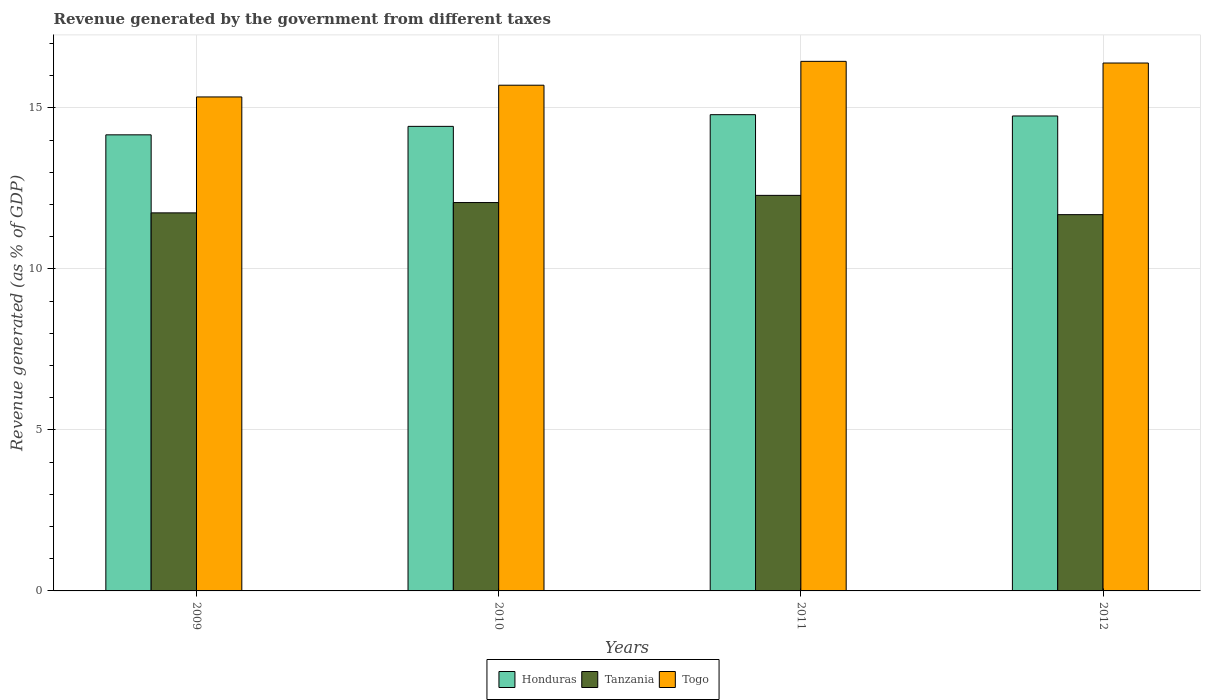Are the number of bars per tick equal to the number of legend labels?
Offer a terse response. Yes. Are the number of bars on each tick of the X-axis equal?
Give a very brief answer. Yes. How many bars are there on the 2nd tick from the right?
Make the answer very short. 3. What is the label of the 3rd group of bars from the left?
Give a very brief answer. 2011. What is the revenue generated by the government in Togo in 2012?
Your response must be concise. 16.39. Across all years, what is the maximum revenue generated by the government in Honduras?
Your response must be concise. 14.79. Across all years, what is the minimum revenue generated by the government in Togo?
Give a very brief answer. 15.34. In which year was the revenue generated by the government in Honduras maximum?
Keep it short and to the point. 2011. In which year was the revenue generated by the government in Togo minimum?
Give a very brief answer. 2009. What is the total revenue generated by the government in Togo in the graph?
Ensure brevity in your answer.  63.88. What is the difference between the revenue generated by the government in Togo in 2010 and that in 2011?
Keep it short and to the point. -0.74. What is the difference between the revenue generated by the government in Tanzania in 2010 and the revenue generated by the government in Honduras in 2012?
Provide a short and direct response. -2.69. What is the average revenue generated by the government in Togo per year?
Offer a very short reply. 15.97. In the year 2009, what is the difference between the revenue generated by the government in Tanzania and revenue generated by the government in Togo?
Your response must be concise. -3.6. What is the ratio of the revenue generated by the government in Tanzania in 2010 to that in 2011?
Offer a very short reply. 0.98. What is the difference between the highest and the second highest revenue generated by the government in Honduras?
Provide a succinct answer. 0.04. What is the difference between the highest and the lowest revenue generated by the government in Honduras?
Ensure brevity in your answer.  0.63. What does the 1st bar from the left in 2012 represents?
Ensure brevity in your answer.  Honduras. What does the 1st bar from the right in 2009 represents?
Your response must be concise. Togo. What is the difference between two consecutive major ticks on the Y-axis?
Your answer should be very brief. 5. Are the values on the major ticks of Y-axis written in scientific E-notation?
Give a very brief answer. No. Does the graph contain any zero values?
Offer a terse response. No. Where does the legend appear in the graph?
Your answer should be compact. Bottom center. How many legend labels are there?
Your answer should be very brief. 3. What is the title of the graph?
Ensure brevity in your answer.  Revenue generated by the government from different taxes. What is the label or title of the Y-axis?
Provide a succinct answer. Revenue generated (as % of GDP). What is the Revenue generated (as % of GDP) of Honduras in 2009?
Keep it short and to the point. 14.16. What is the Revenue generated (as % of GDP) of Tanzania in 2009?
Provide a succinct answer. 11.74. What is the Revenue generated (as % of GDP) of Togo in 2009?
Your answer should be very brief. 15.34. What is the Revenue generated (as % of GDP) in Honduras in 2010?
Make the answer very short. 14.43. What is the Revenue generated (as % of GDP) of Tanzania in 2010?
Your response must be concise. 12.06. What is the Revenue generated (as % of GDP) of Togo in 2010?
Give a very brief answer. 15.7. What is the Revenue generated (as % of GDP) of Honduras in 2011?
Make the answer very short. 14.79. What is the Revenue generated (as % of GDP) in Tanzania in 2011?
Your answer should be very brief. 12.28. What is the Revenue generated (as % of GDP) of Togo in 2011?
Make the answer very short. 16.44. What is the Revenue generated (as % of GDP) of Honduras in 2012?
Give a very brief answer. 14.75. What is the Revenue generated (as % of GDP) of Tanzania in 2012?
Offer a very short reply. 11.68. What is the Revenue generated (as % of GDP) in Togo in 2012?
Your response must be concise. 16.39. Across all years, what is the maximum Revenue generated (as % of GDP) in Honduras?
Ensure brevity in your answer.  14.79. Across all years, what is the maximum Revenue generated (as % of GDP) in Tanzania?
Offer a very short reply. 12.28. Across all years, what is the maximum Revenue generated (as % of GDP) of Togo?
Give a very brief answer. 16.44. Across all years, what is the minimum Revenue generated (as % of GDP) of Honduras?
Provide a short and direct response. 14.16. Across all years, what is the minimum Revenue generated (as % of GDP) in Tanzania?
Your answer should be compact. 11.68. Across all years, what is the minimum Revenue generated (as % of GDP) in Togo?
Offer a terse response. 15.34. What is the total Revenue generated (as % of GDP) of Honduras in the graph?
Your answer should be very brief. 58.12. What is the total Revenue generated (as % of GDP) of Tanzania in the graph?
Your answer should be compact. 47.76. What is the total Revenue generated (as % of GDP) in Togo in the graph?
Your answer should be compact. 63.88. What is the difference between the Revenue generated (as % of GDP) in Honduras in 2009 and that in 2010?
Keep it short and to the point. -0.26. What is the difference between the Revenue generated (as % of GDP) in Tanzania in 2009 and that in 2010?
Your response must be concise. -0.32. What is the difference between the Revenue generated (as % of GDP) of Togo in 2009 and that in 2010?
Offer a terse response. -0.36. What is the difference between the Revenue generated (as % of GDP) in Honduras in 2009 and that in 2011?
Your answer should be very brief. -0.63. What is the difference between the Revenue generated (as % of GDP) in Tanzania in 2009 and that in 2011?
Provide a succinct answer. -0.54. What is the difference between the Revenue generated (as % of GDP) in Togo in 2009 and that in 2011?
Provide a succinct answer. -1.1. What is the difference between the Revenue generated (as % of GDP) of Honduras in 2009 and that in 2012?
Your answer should be compact. -0.59. What is the difference between the Revenue generated (as % of GDP) in Tanzania in 2009 and that in 2012?
Give a very brief answer. 0.06. What is the difference between the Revenue generated (as % of GDP) in Togo in 2009 and that in 2012?
Make the answer very short. -1.05. What is the difference between the Revenue generated (as % of GDP) in Honduras in 2010 and that in 2011?
Offer a very short reply. -0.36. What is the difference between the Revenue generated (as % of GDP) of Tanzania in 2010 and that in 2011?
Your answer should be very brief. -0.22. What is the difference between the Revenue generated (as % of GDP) in Togo in 2010 and that in 2011?
Give a very brief answer. -0.74. What is the difference between the Revenue generated (as % of GDP) in Honduras in 2010 and that in 2012?
Your response must be concise. -0.32. What is the difference between the Revenue generated (as % of GDP) of Tanzania in 2010 and that in 2012?
Offer a terse response. 0.38. What is the difference between the Revenue generated (as % of GDP) of Togo in 2010 and that in 2012?
Provide a short and direct response. -0.69. What is the difference between the Revenue generated (as % of GDP) of Honduras in 2011 and that in 2012?
Make the answer very short. 0.04. What is the difference between the Revenue generated (as % of GDP) in Tanzania in 2011 and that in 2012?
Provide a short and direct response. 0.6. What is the difference between the Revenue generated (as % of GDP) of Togo in 2011 and that in 2012?
Make the answer very short. 0.05. What is the difference between the Revenue generated (as % of GDP) in Honduras in 2009 and the Revenue generated (as % of GDP) in Tanzania in 2010?
Offer a very short reply. 2.1. What is the difference between the Revenue generated (as % of GDP) of Honduras in 2009 and the Revenue generated (as % of GDP) of Togo in 2010?
Provide a short and direct response. -1.54. What is the difference between the Revenue generated (as % of GDP) of Tanzania in 2009 and the Revenue generated (as % of GDP) of Togo in 2010?
Make the answer very short. -3.96. What is the difference between the Revenue generated (as % of GDP) of Honduras in 2009 and the Revenue generated (as % of GDP) of Tanzania in 2011?
Keep it short and to the point. 1.88. What is the difference between the Revenue generated (as % of GDP) of Honduras in 2009 and the Revenue generated (as % of GDP) of Togo in 2011?
Keep it short and to the point. -2.28. What is the difference between the Revenue generated (as % of GDP) of Tanzania in 2009 and the Revenue generated (as % of GDP) of Togo in 2011?
Make the answer very short. -4.7. What is the difference between the Revenue generated (as % of GDP) in Honduras in 2009 and the Revenue generated (as % of GDP) in Tanzania in 2012?
Provide a succinct answer. 2.48. What is the difference between the Revenue generated (as % of GDP) in Honduras in 2009 and the Revenue generated (as % of GDP) in Togo in 2012?
Make the answer very short. -2.23. What is the difference between the Revenue generated (as % of GDP) in Tanzania in 2009 and the Revenue generated (as % of GDP) in Togo in 2012?
Your answer should be compact. -4.65. What is the difference between the Revenue generated (as % of GDP) in Honduras in 2010 and the Revenue generated (as % of GDP) in Tanzania in 2011?
Provide a short and direct response. 2.14. What is the difference between the Revenue generated (as % of GDP) in Honduras in 2010 and the Revenue generated (as % of GDP) in Togo in 2011?
Offer a terse response. -2.02. What is the difference between the Revenue generated (as % of GDP) of Tanzania in 2010 and the Revenue generated (as % of GDP) of Togo in 2011?
Keep it short and to the point. -4.38. What is the difference between the Revenue generated (as % of GDP) in Honduras in 2010 and the Revenue generated (as % of GDP) in Tanzania in 2012?
Provide a succinct answer. 2.74. What is the difference between the Revenue generated (as % of GDP) of Honduras in 2010 and the Revenue generated (as % of GDP) of Togo in 2012?
Give a very brief answer. -1.97. What is the difference between the Revenue generated (as % of GDP) in Tanzania in 2010 and the Revenue generated (as % of GDP) in Togo in 2012?
Your answer should be compact. -4.33. What is the difference between the Revenue generated (as % of GDP) of Honduras in 2011 and the Revenue generated (as % of GDP) of Tanzania in 2012?
Make the answer very short. 3.1. What is the difference between the Revenue generated (as % of GDP) in Honduras in 2011 and the Revenue generated (as % of GDP) in Togo in 2012?
Provide a short and direct response. -1.6. What is the difference between the Revenue generated (as % of GDP) in Tanzania in 2011 and the Revenue generated (as % of GDP) in Togo in 2012?
Keep it short and to the point. -4.11. What is the average Revenue generated (as % of GDP) in Honduras per year?
Give a very brief answer. 14.53. What is the average Revenue generated (as % of GDP) of Tanzania per year?
Your answer should be compact. 11.94. What is the average Revenue generated (as % of GDP) in Togo per year?
Keep it short and to the point. 15.97. In the year 2009, what is the difference between the Revenue generated (as % of GDP) of Honduras and Revenue generated (as % of GDP) of Tanzania?
Give a very brief answer. 2.42. In the year 2009, what is the difference between the Revenue generated (as % of GDP) in Honduras and Revenue generated (as % of GDP) in Togo?
Keep it short and to the point. -1.18. In the year 2009, what is the difference between the Revenue generated (as % of GDP) in Tanzania and Revenue generated (as % of GDP) in Togo?
Ensure brevity in your answer.  -3.6. In the year 2010, what is the difference between the Revenue generated (as % of GDP) of Honduras and Revenue generated (as % of GDP) of Tanzania?
Provide a short and direct response. 2.37. In the year 2010, what is the difference between the Revenue generated (as % of GDP) of Honduras and Revenue generated (as % of GDP) of Togo?
Provide a succinct answer. -1.28. In the year 2010, what is the difference between the Revenue generated (as % of GDP) in Tanzania and Revenue generated (as % of GDP) in Togo?
Offer a very short reply. -3.64. In the year 2011, what is the difference between the Revenue generated (as % of GDP) in Honduras and Revenue generated (as % of GDP) in Tanzania?
Provide a succinct answer. 2.51. In the year 2011, what is the difference between the Revenue generated (as % of GDP) in Honduras and Revenue generated (as % of GDP) in Togo?
Your response must be concise. -1.66. In the year 2011, what is the difference between the Revenue generated (as % of GDP) in Tanzania and Revenue generated (as % of GDP) in Togo?
Offer a terse response. -4.16. In the year 2012, what is the difference between the Revenue generated (as % of GDP) of Honduras and Revenue generated (as % of GDP) of Tanzania?
Your answer should be compact. 3.06. In the year 2012, what is the difference between the Revenue generated (as % of GDP) of Honduras and Revenue generated (as % of GDP) of Togo?
Ensure brevity in your answer.  -1.64. In the year 2012, what is the difference between the Revenue generated (as % of GDP) of Tanzania and Revenue generated (as % of GDP) of Togo?
Ensure brevity in your answer.  -4.71. What is the ratio of the Revenue generated (as % of GDP) of Honduras in 2009 to that in 2010?
Offer a terse response. 0.98. What is the ratio of the Revenue generated (as % of GDP) of Tanzania in 2009 to that in 2010?
Keep it short and to the point. 0.97. What is the ratio of the Revenue generated (as % of GDP) in Togo in 2009 to that in 2010?
Ensure brevity in your answer.  0.98. What is the ratio of the Revenue generated (as % of GDP) in Honduras in 2009 to that in 2011?
Give a very brief answer. 0.96. What is the ratio of the Revenue generated (as % of GDP) of Tanzania in 2009 to that in 2011?
Give a very brief answer. 0.96. What is the ratio of the Revenue generated (as % of GDP) in Togo in 2009 to that in 2011?
Offer a terse response. 0.93. What is the ratio of the Revenue generated (as % of GDP) in Honduras in 2009 to that in 2012?
Offer a very short reply. 0.96. What is the ratio of the Revenue generated (as % of GDP) in Togo in 2009 to that in 2012?
Offer a very short reply. 0.94. What is the ratio of the Revenue generated (as % of GDP) in Honduras in 2010 to that in 2011?
Your answer should be very brief. 0.98. What is the ratio of the Revenue generated (as % of GDP) of Tanzania in 2010 to that in 2011?
Your answer should be compact. 0.98. What is the ratio of the Revenue generated (as % of GDP) in Togo in 2010 to that in 2011?
Provide a short and direct response. 0.95. What is the ratio of the Revenue generated (as % of GDP) in Honduras in 2010 to that in 2012?
Provide a short and direct response. 0.98. What is the ratio of the Revenue generated (as % of GDP) of Tanzania in 2010 to that in 2012?
Provide a short and direct response. 1.03. What is the ratio of the Revenue generated (as % of GDP) of Togo in 2010 to that in 2012?
Ensure brevity in your answer.  0.96. What is the ratio of the Revenue generated (as % of GDP) of Honduras in 2011 to that in 2012?
Provide a succinct answer. 1. What is the ratio of the Revenue generated (as % of GDP) in Tanzania in 2011 to that in 2012?
Your answer should be very brief. 1.05. What is the difference between the highest and the second highest Revenue generated (as % of GDP) in Honduras?
Provide a short and direct response. 0.04. What is the difference between the highest and the second highest Revenue generated (as % of GDP) in Tanzania?
Your answer should be very brief. 0.22. What is the difference between the highest and the second highest Revenue generated (as % of GDP) in Togo?
Provide a succinct answer. 0.05. What is the difference between the highest and the lowest Revenue generated (as % of GDP) of Honduras?
Keep it short and to the point. 0.63. What is the difference between the highest and the lowest Revenue generated (as % of GDP) in Tanzania?
Offer a very short reply. 0.6. What is the difference between the highest and the lowest Revenue generated (as % of GDP) of Togo?
Your response must be concise. 1.1. 